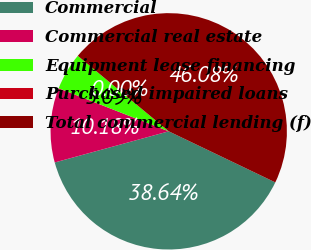Convert chart to OTSL. <chart><loc_0><loc_0><loc_500><loc_500><pie_chart><fcel>Commercial<fcel>Commercial real estate<fcel>Equipment lease financing<fcel>Purchased impaired loans<fcel>Total commercial lending (f)<nl><fcel>38.64%<fcel>10.18%<fcel>5.09%<fcel>0.0%<fcel>46.08%<nl></chart> 